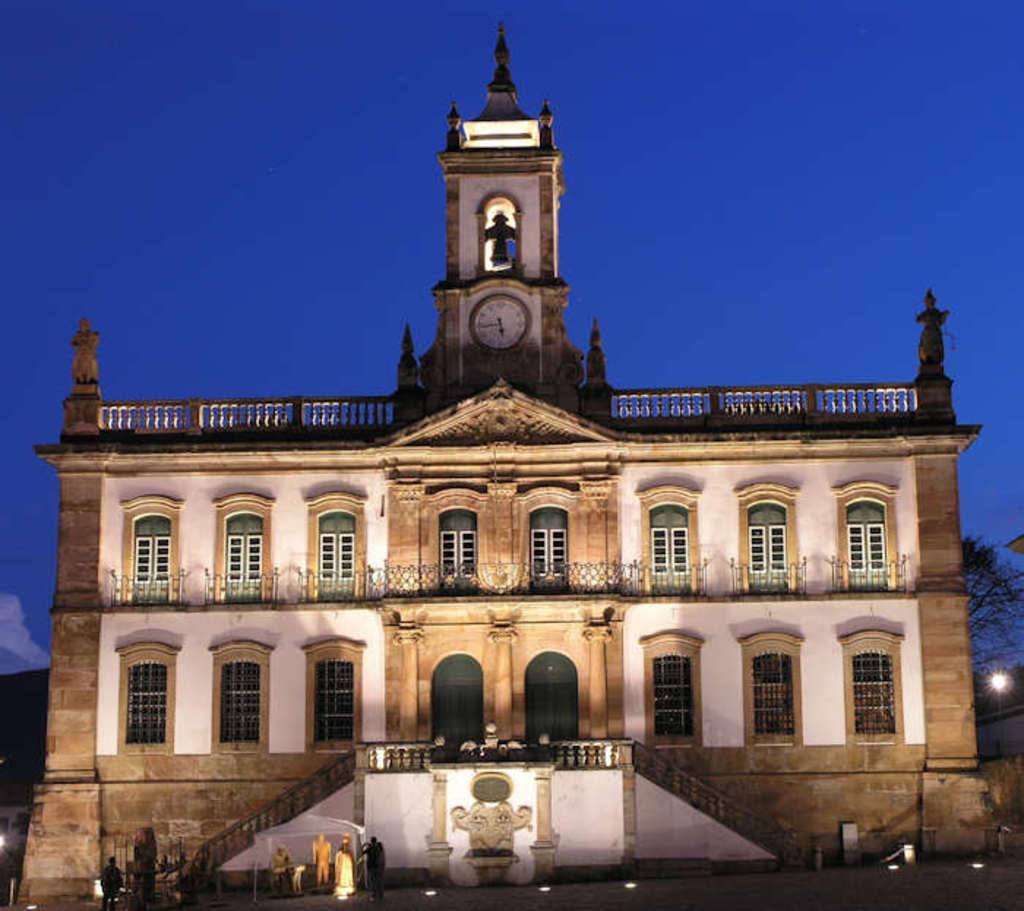Please provide a concise description of this image. In this image we can see a building with windows, railing, staircase and a clock on a wall. We can also see a tree, lights and the sky which looks cloudy. On the bottom of the image we can see a pole and some people standing on the ground. 